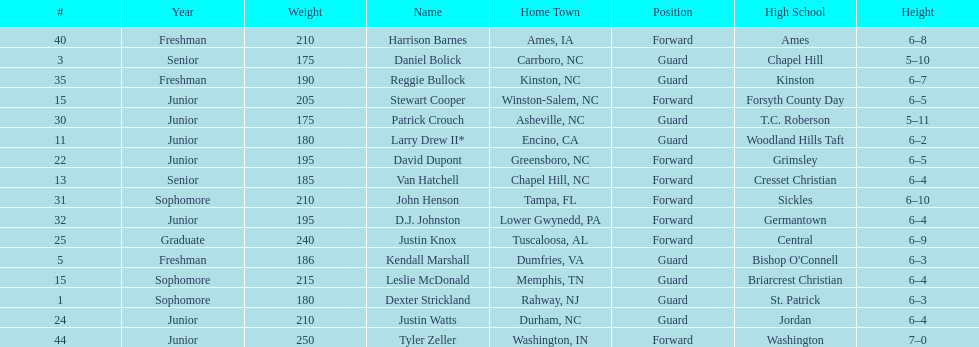What is the number of players with a weight over 200? 7. 